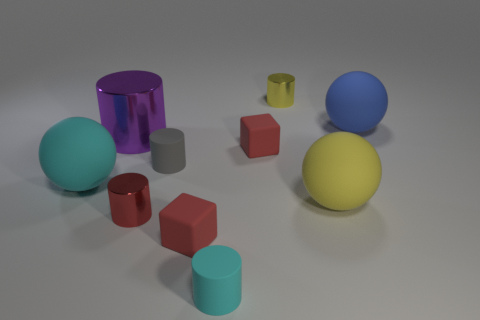There is a big shiny object that is the same shape as the small cyan object; what is its color?
Provide a succinct answer. Purple. What number of objects are either matte balls to the left of the big purple shiny cylinder or large purple rubber blocks?
Offer a very short reply. 1. How big is the yellow shiny thing?
Give a very brief answer. Small. There is a block right of the cyan rubber object in front of the yellow rubber object; what is its material?
Your response must be concise. Rubber. Do the cyan thing that is behind the yellow matte ball and the big blue rubber thing have the same size?
Provide a succinct answer. Yes. Is there a small thing that has the same color as the big shiny object?
Keep it short and to the point. No. How many things are either cylinders that are in front of the tiny yellow shiny cylinder or large matte things that are behind the large yellow sphere?
Ensure brevity in your answer.  6. Is the number of cyan objects that are behind the tiny red cylinder less than the number of small objects behind the gray rubber cylinder?
Provide a short and direct response. Yes. Is the material of the large cyan object the same as the red cylinder?
Provide a succinct answer. No. What size is the metallic object that is both behind the big yellow object and right of the big purple metal cylinder?
Ensure brevity in your answer.  Small. 